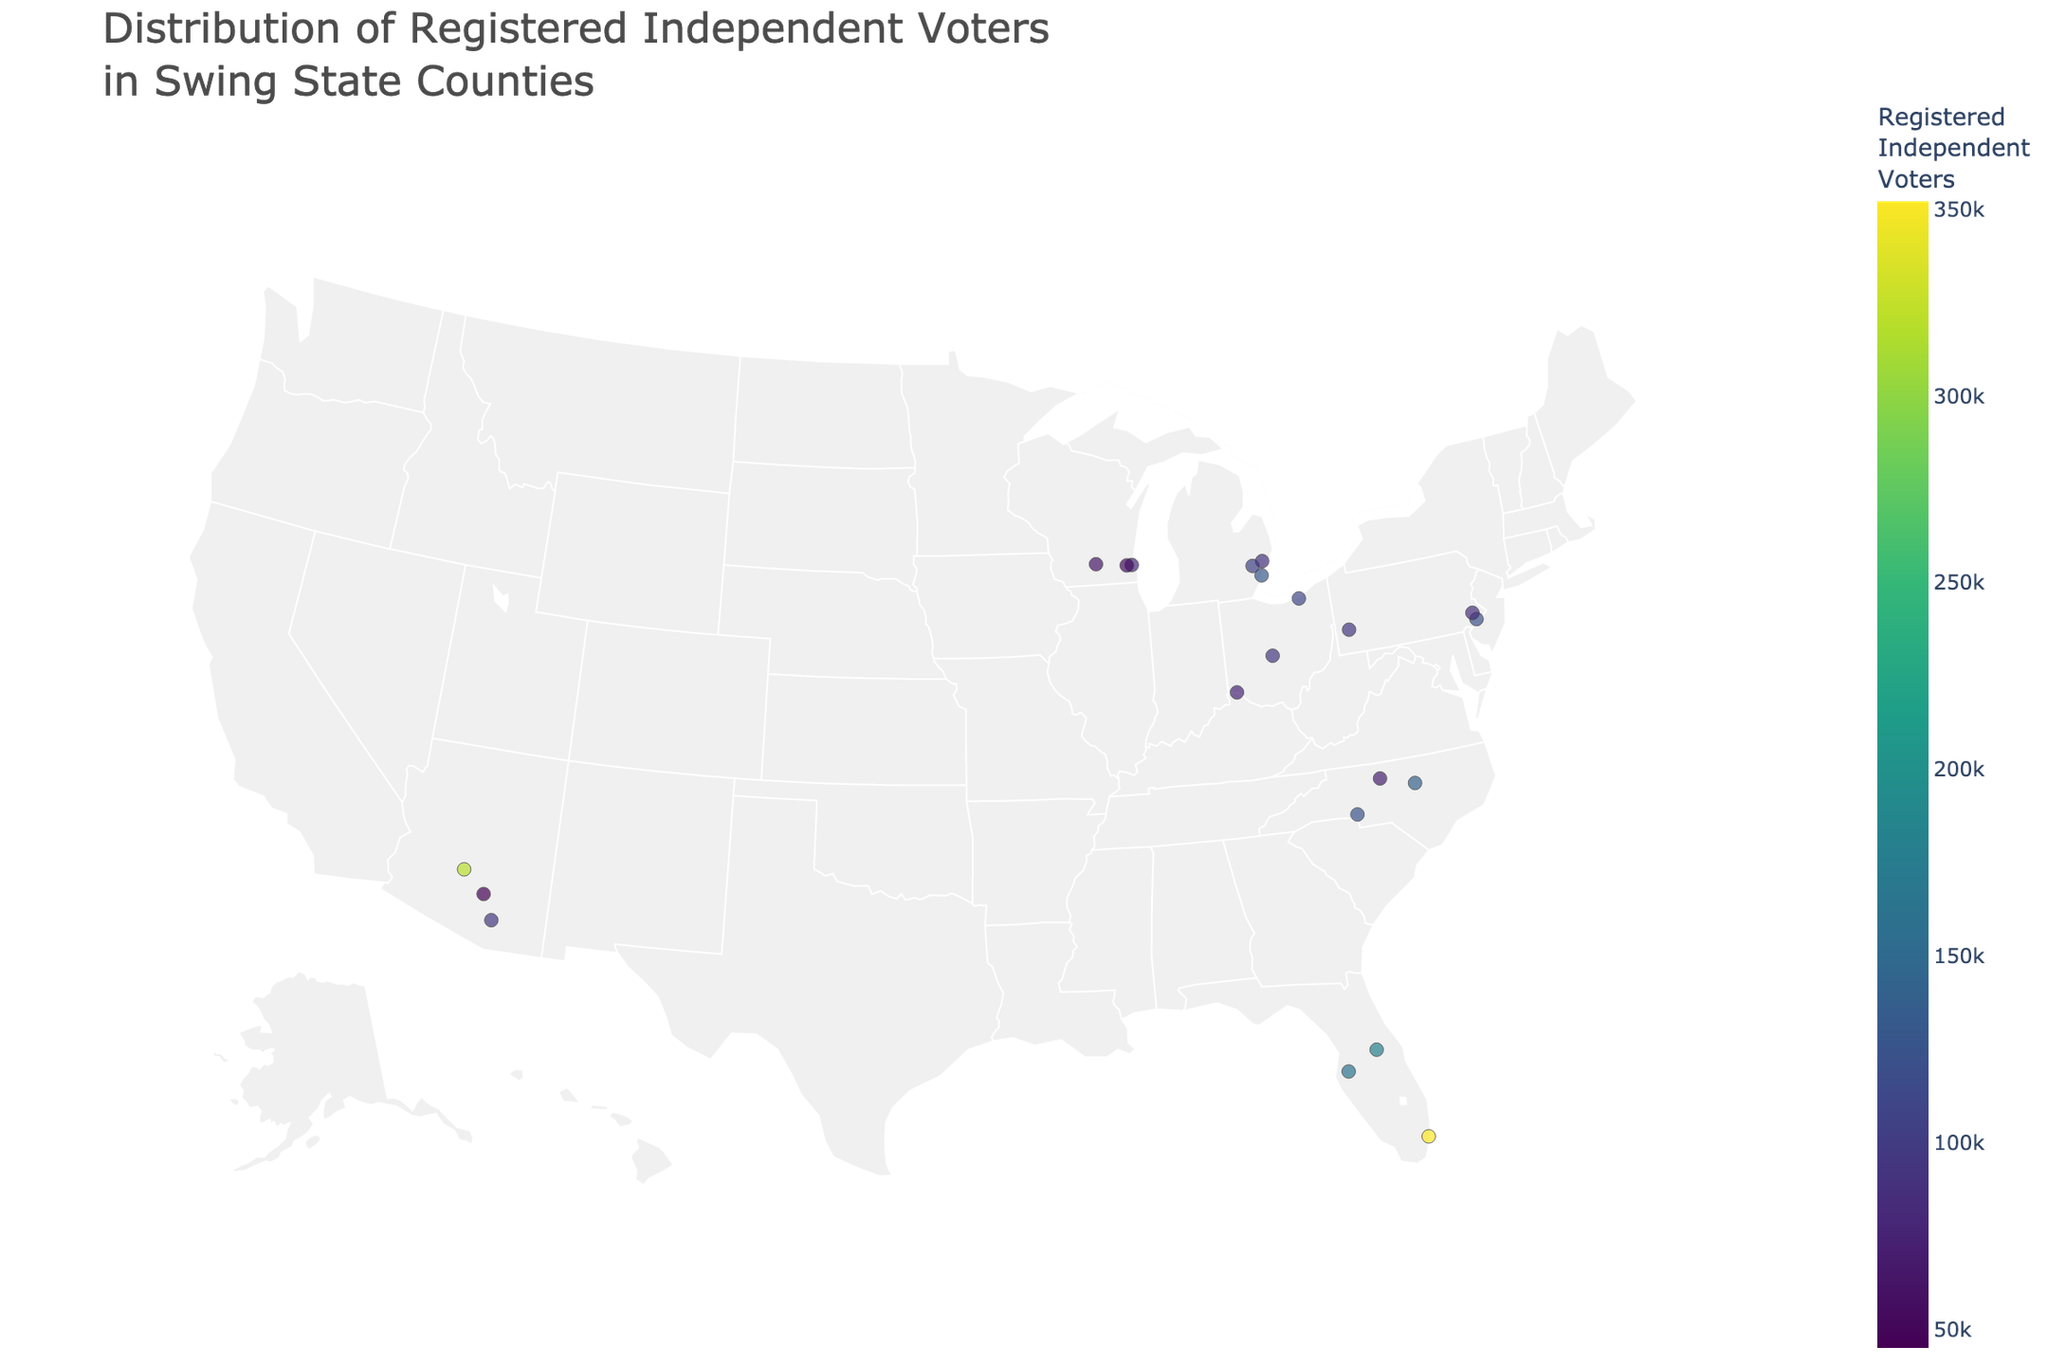What's the title of the figure? The title is usually prominently displayed at the top of the figure. It serves as a summary of what the figure represents. In this case, the title reads 'Distribution of Registered Independent Voters in Swing State Counties'.
Answer: Distribution of Registered Independent Voters in Swing State Counties What state has the county with the highest number of registered independent voters? By examining the map and tooltip details, we can see that Maricopa county in Arizona has the highest number of registered independent voters, amounting to 320,000.
Answer: Arizona How many counties have more than 300,000 registered independent voters? By observing the markers and their sizes/colors, we can see that only Miami-Dade (Florida) with 352,000 and Maricopa (Arizona) with 320,000 have more than 300,000 registered independent voters.
Answer: 2 Which county in Pennsylvania has the most registered independent voters? Viewing the frequencies in the figure and tooltips, Philadelphia county stands out with the most registered independent voters at 120,000.
Answer: Philadelphia Compare the number of registered independent voters in Wake county, North Carolina, to Dane county, Wisconsin. Which has more? By looking at the colored markers and tooltips, we see that Wake county has 140,000 registered independent voters, while Dane county has 65,000. Thus, Wake county has more.
Answer: Wake county What is the combined total of registered independent voters for the three counties in Michigan? Adding the numbers from the figure for Wayne (130,000), Oakland (105,000), and Macomb (90,000) gives a total combined number of 325,000.
Answer: 325,000 Which state has the most counties listed in the plot? By counting the number of counties per state, we see that Florida has the most counties listed with three: Miami-Dade, Orange, and Hillsborough.
Answer: Florida What is the difference in registered independent voters between Philadelphia county and Hamilton county? Referring to the tooltip data from the figure, Philadelphia county has 120,000 registered independent voters and Hamilton county has 75,000. The difference is 120,000 - 75,000 = 45,000.
Answer: 45,000 Which county in Ohio has the smallest number of registered independent voters? By examining the markers and tooltip data for Ohio, we see that Hamilton county, with 75,000 registered independent voters, has the smallest number among the listed counties in Ohio.
Answer: Hamilton county 